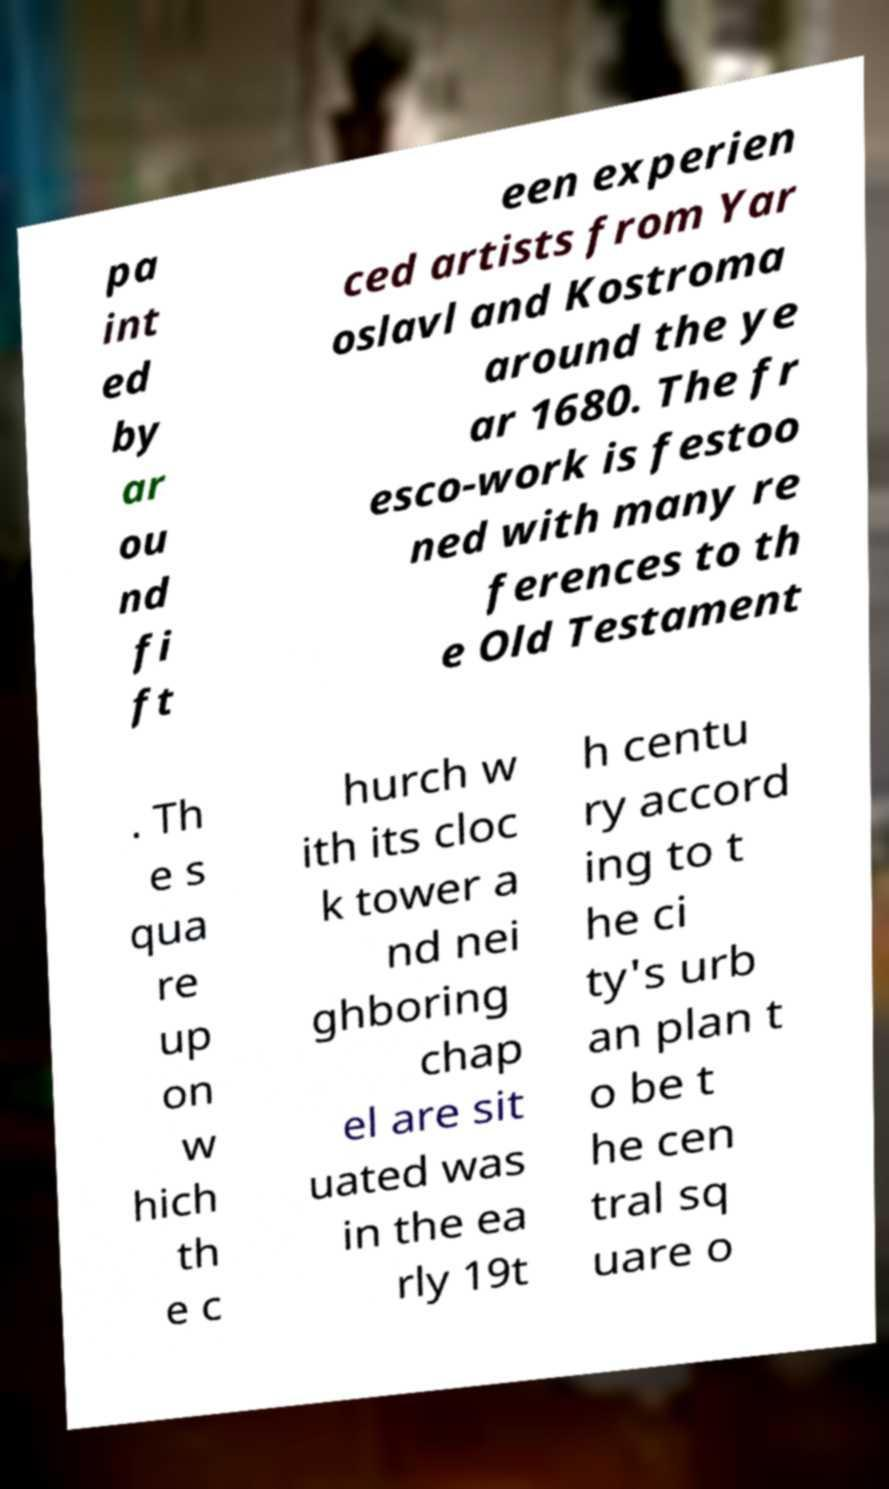There's text embedded in this image that I need extracted. Can you transcribe it verbatim? pa int ed by ar ou nd fi ft een experien ced artists from Yar oslavl and Kostroma around the ye ar 1680. The fr esco-work is festoo ned with many re ferences to th e Old Testament . Th e s qua re up on w hich th e c hurch w ith its cloc k tower a nd nei ghboring chap el are sit uated was in the ea rly 19t h centu ry accord ing to t he ci ty's urb an plan t o be t he cen tral sq uare o 